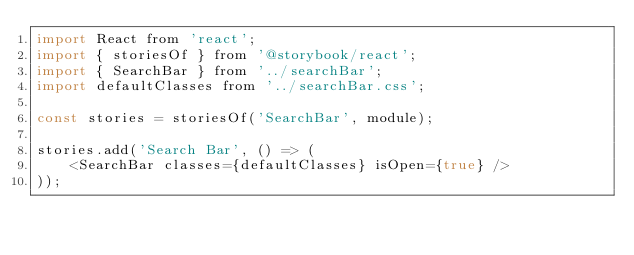Convert code to text. <code><loc_0><loc_0><loc_500><loc_500><_JavaScript_>import React from 'react';
import { storiesOf } from '@storybook/react';
import { SearchBar } from '../searchBar';
import defaultClasses from '../searchBar.css';

const stories = storiesOf('SearchBar', module);

stories.add('Search Bar', () => (
    <SearchBar classes={defaultClasses} isOpen={true} />
));
</code> 